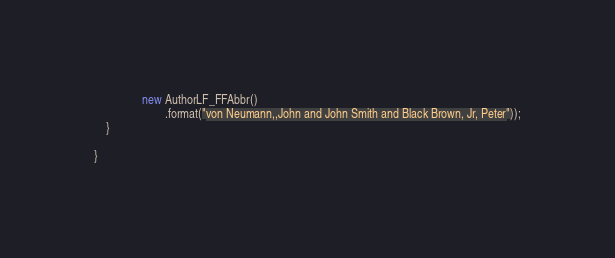Convert code to text. <code><loc_0><loc_0><loc_500><loc_500><_Java_>                new AuthorLF_FFAbbr()
                        .format("von Neumann,,John and John Smith and Black Brown, Jr, Peter"));
    }

}
</code> 